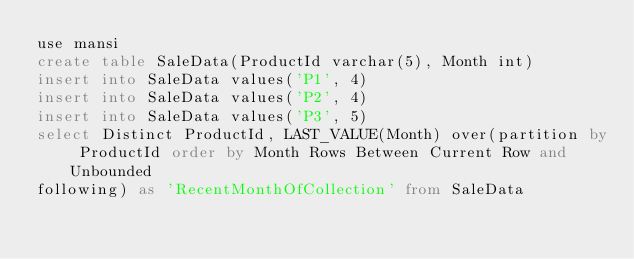Convert code to text. <code><loc_0><loc_0><loc_500><loc_500><_SQL_>use mansi
create table SaleData(ProductId varchar(5), Month int)
insert into SaleData values('P1', 4)
insert into SaleData values('P2', 4)
insert into SaleData values('P3', 5)
select Distinct ProductId, LAST_VALUE(Month) over(partition by ProductId order by Month Rows Between Current Row and Unbounded
following) as 'RecentMonthOfCollection' from SaleData</code> 